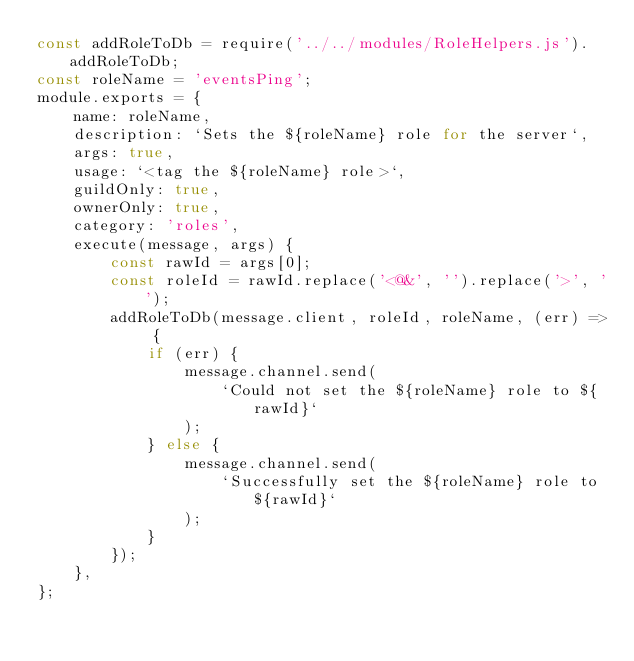<code> <loc_0><loc_0><loc_500><loc_500><_JavaScript_>const addRoleToDb = require('../../modules/RoleHelpers.js').addRoleToDb;
const roleName = 'eventsPing';
module.exports = {
    name: roleName,
    description: `Sets the ${roleName} role for the server`,
    args: true,
    usage: `<tag the ${roleName} role>`,
    guildOnly: true,
    ownerOnly: true,
    category: 'roles',
    execute(message, args) {
        const rawId = args[0];
        const roleId = rawId.replace('<@&', '').replace('>', '');
        addRoleToDb(message.client, roleId, roleName, (err) => {
            if (err) {
                message.channel.send(
                    `Could not set the ${roleName} role to ${rawId}`
                );
            } else {
                message.channel.send(
                    `Successfully set the ${roleName} role to ${rawId}`
                );
            }
        });
    },
};
</code> 